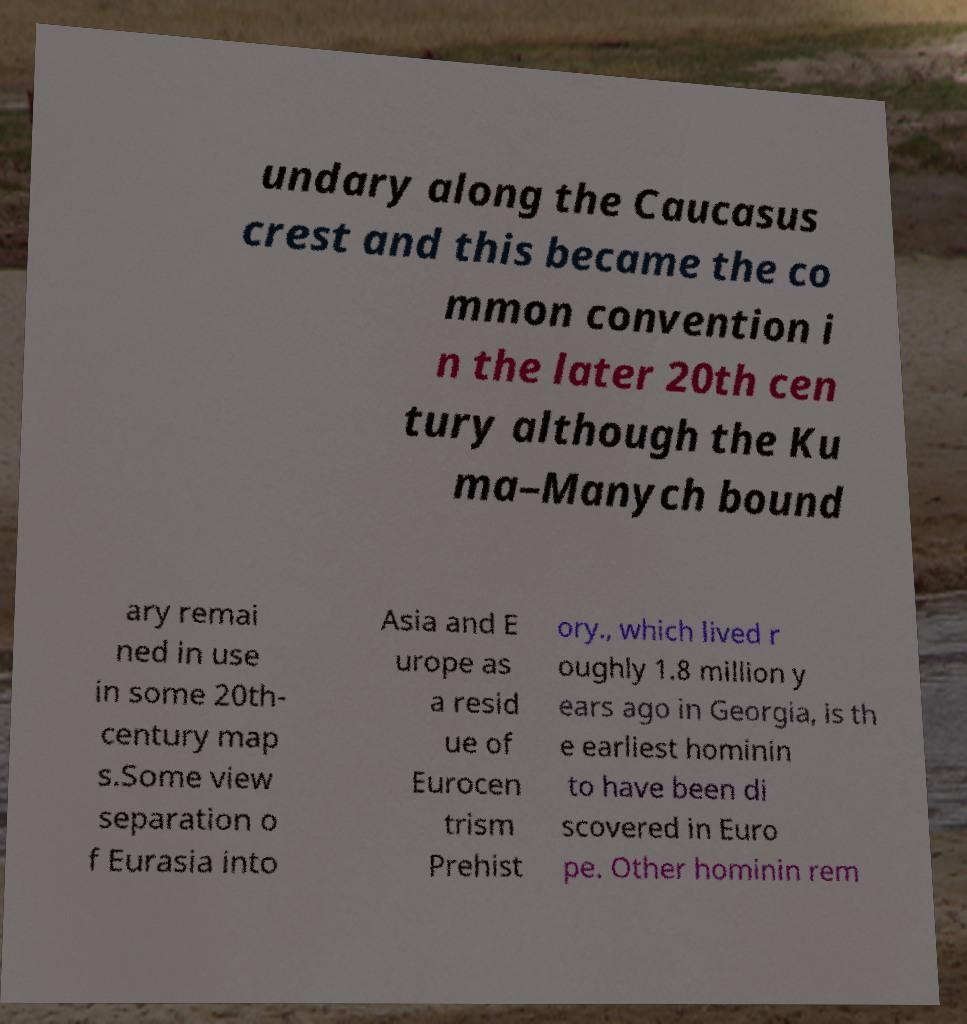For documentation purposes, I need the text within this image transcribed. Could you provide that? undary along the Caucasus crest and this became the co mmon convention i n the later 20th cen tury although the Ku ma–Manych bound ary remai ned in use in some 20th- century map s.Some view separation o f Eurasia into Asia and E urope as a resid ue of Eurocen trism Prehist ory., which lived r oughly 1.8 million y ears ago in Georgia, is th e earliest hominin to have been di scovered in Euro pe. Other hominin rem 